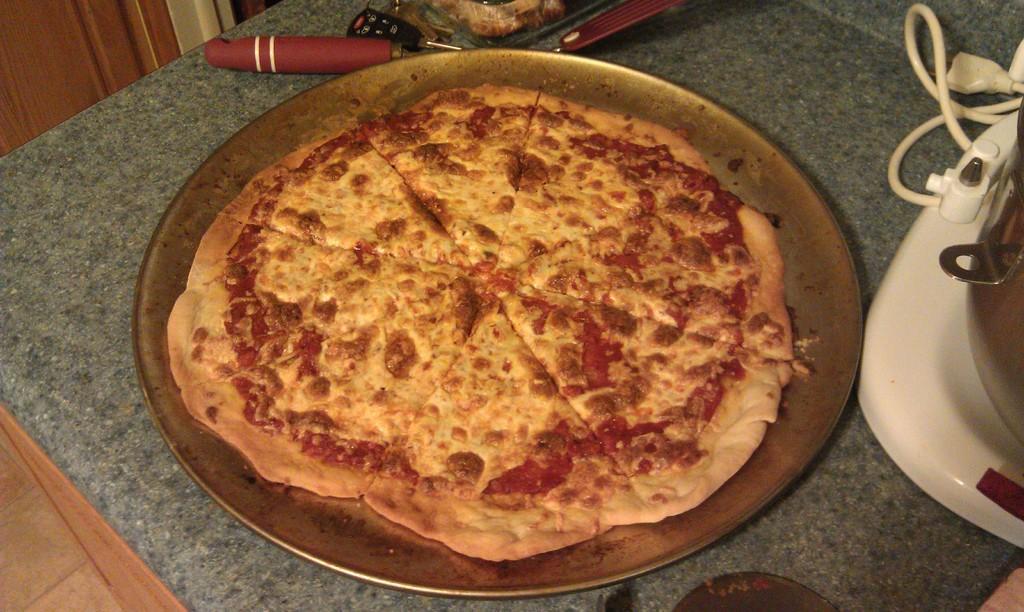Could you give a brief overview of what you see in this image? In this image we can see food on a plate. Beside the plate we can see few objects. In the top left, we can see a wooden object. 